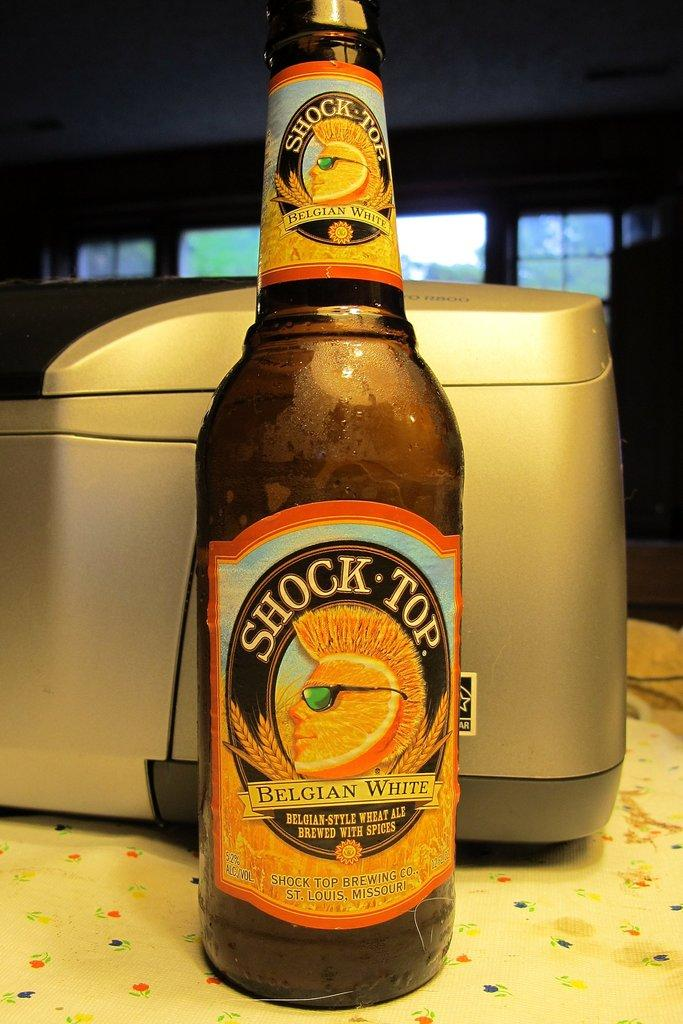What device is present in the image? There is a printer in the image. What can be seen on the table in the image? There is a beer bottle on the table in the image. What architectural feature is visible in the image? There is a window in the image. What is visible through the window in the image? Trees are visible through the window in the image. What color is the sweater worn by the person in the image? There is no person wearing a sweater in the image. How many mittens are visible in the image? There are no mittens present in the image. 